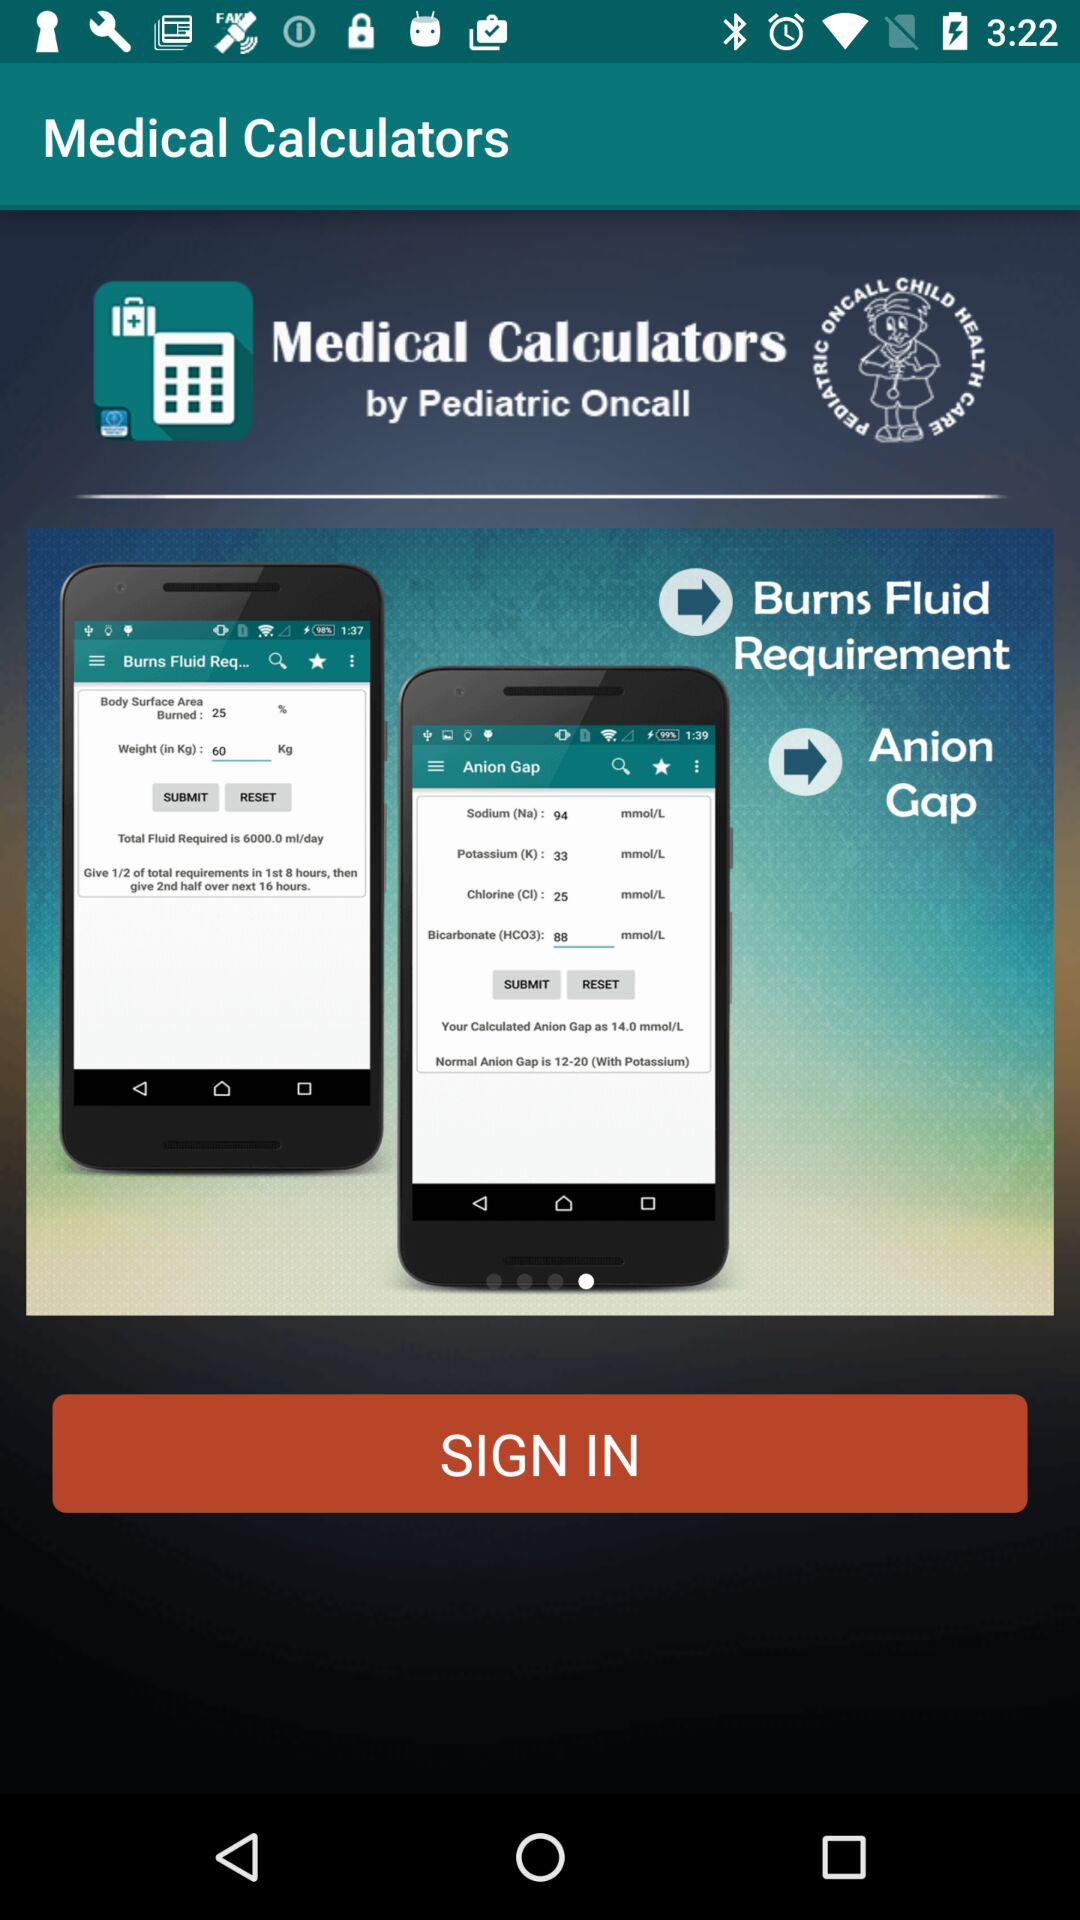What is the name of the application? The name of the application is "Medical Calculators". 